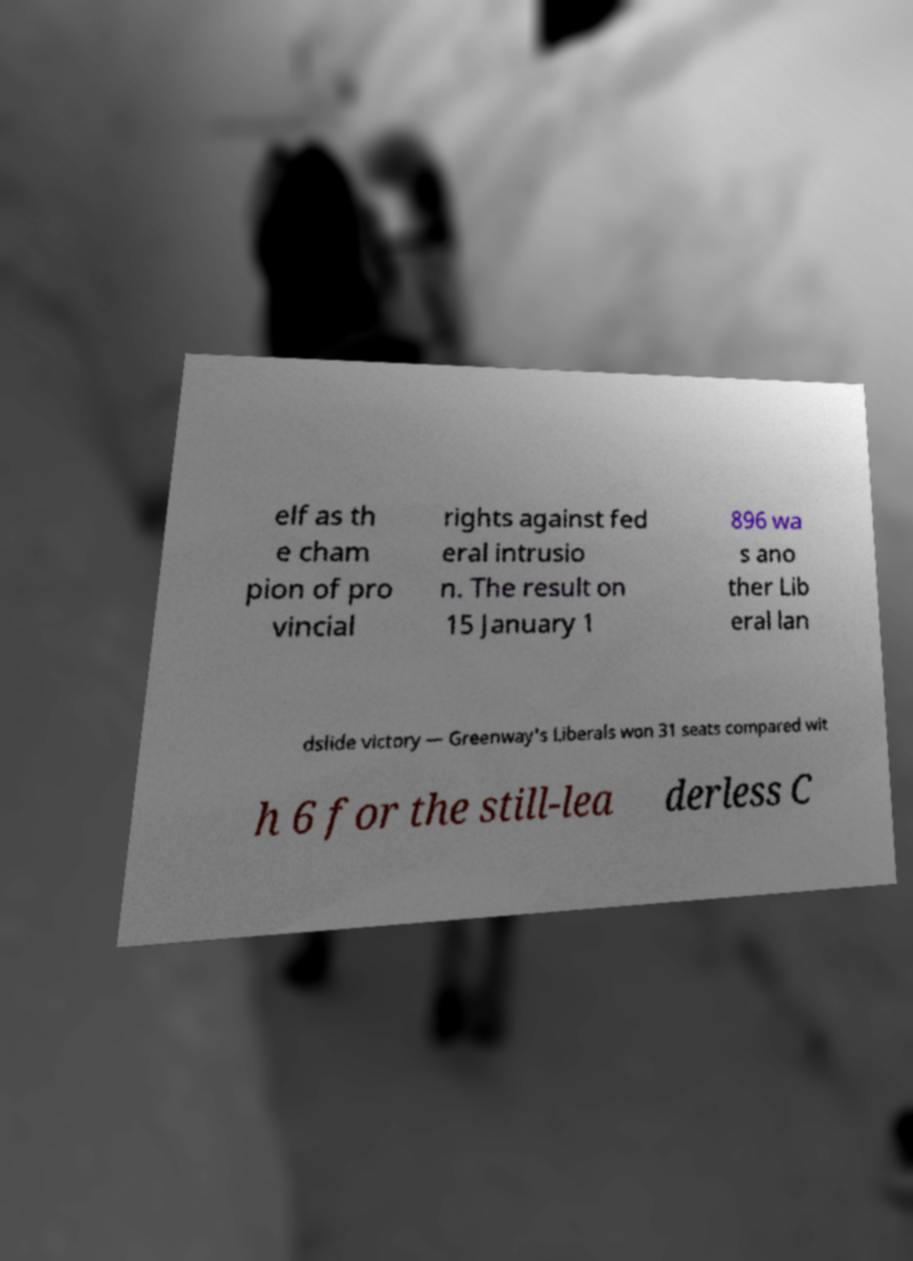I need the written content from this picture converted into text. Can you do that? elf as th e cham pion of pro vincial rights against fed eral intrusio n. The result on 15 January 1 896 wa s ano ther Lib eral lan dslide victory — Greenway's Liberals won 31 seats compared wit h 6 for the still-lea derless C 